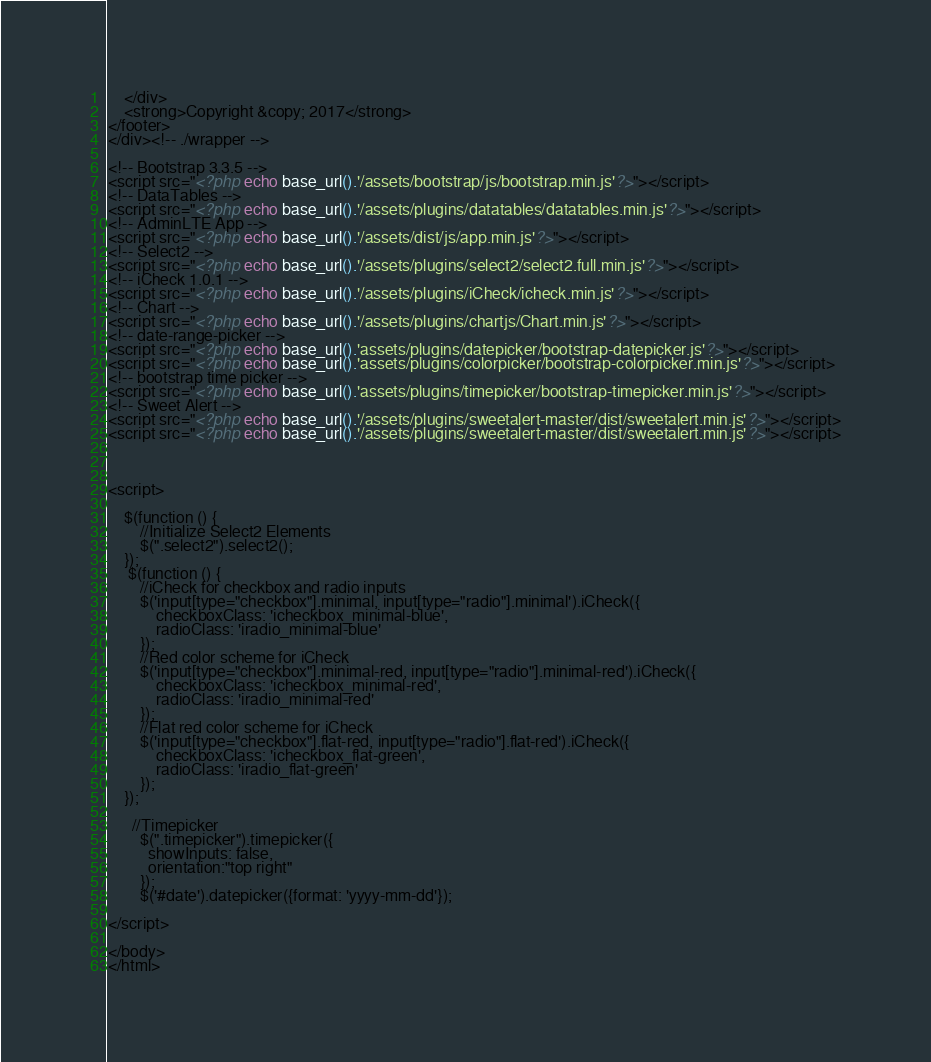Convert code to text. <code><loc_0><loc_0><loc_500><loc_500><_PHP_>    </div>
    <strong>Copyright &copy; 2017</strong>
</footer>
</div><!-- ./wrapper -->

<!-- Bootstrap 3.3.5 -->
<script src="<?php echo base_url().'/assets/bootstrap/js/bootstrap.min.js'?>"></script>
<!-- DataTables -->
<script src="<?php echo base_url().'/assets/plugins/datatables/datatables.min.js'?>"></script>
<!-- AdminLTE App -->
<script src="<?php echo base_url().'/assets/dist/js/app.min.js'?>"></script>
<!-- Select2 -->
<script src="<?php echo base_url().'/assets/plugins/select2/select2.full.min.js'?>"></script>
<!-- iCheck 1.0.1 -->
<script src="<?php echo base_url().'/assets/plugins/iCheck/icheck.min.js'?>"></script>
<!-- Chart -->
<script src="<?php echo base_url().'/assets/plugins/chartjs/Chart.min.js'?>"></script>
<!-- date-range-picker -->
<script src="<?php echo base_url().'assets/plugins/datepicker/bootstrap-datepicker.js'?>"></script>
<script src="<?php echo base_url().'assets/plugins/colorpicker/bootstrap-colorpicker.min.js'?>"></script>
<!-- bootstrap time picker -->
<script src="<?php echo base_url().'assets/plugins/timepicker/bootstrap-timepicker.min.js'?>"></script>
<!-- Sweet Alert -->
<script src="<?php echo base_url().'/assets/plugins/sweetalert-master/dist/sweetalert.min.js'?>"></script>
<script src="<?php echo base_url().'/assets/plugins/sweetalert-master/dist/sweetalert.min.js'?>"></script>


    
<script>
  
    $(function () {
        //Initialize Select2 Elements
        $(".select2").select2();
    });
     $(function () {
        //iCheck for checkbox and radio inputs
        $('input[type="checkbox"].minimal, input[type="radio"].minimal').iCheck({
            checkboxClass: 'icheckbox_minimal-blue',
            radioClass: 'iradio_minimal-blue'
        });
        //Red color scheme for iCheck
        $('input[type="checkbox"].minimal-red, input[type="radio"].minimal-red').iCheck({
            checkboxClass: 'icheckbox_minimal-red',
            radioClass: 'iradio_minimal-red'
        });
        //Flat red color scheme for iCheck
        $('input[type="checkbox"].flat-red, input[type="radio"].flat-red').iCheck({
            checkboxClass: 'icheckbox_flat-green',
            radioClass: 'iradio_flat-green'
        });
    });

      //Timepicker
        $(".timepicker").timepicker({
          showInputs: false,
          orientation:"top right"
        });
        $('#date').datepicker({format: 'yyyy-mm-dd'});

</script>

</body>
</html>
</code> 